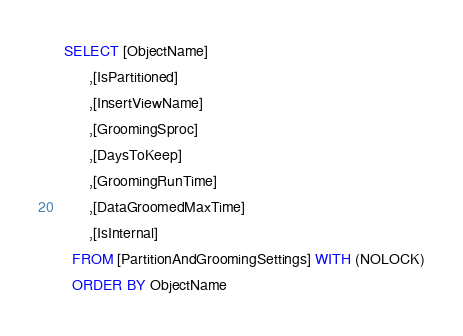<code> <loc_0><loc_0><loc_500><loc_500><_SQL_>SELECT [ObjectName]
      ,[IsPartitioned]
      ,[InsertViewName]
      ,[GroomingSproc]
      ,[DaysToKeep]
      ,[GroomingRunTime]
      ,[DataGroomedMaxTime]
      ,[IsInternal]
  FROM [PartitionAndGroomingSettings] WITH (NOLOCK)
  ORDER BY ObjectName
</code> 